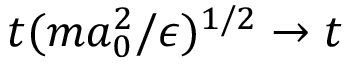<formula> <loc_0><loc_0><loc_500><loc_500>t ( m a _ { 0 } ^ { 2 } / \epsilon ) ^ { 1 / 2 } \rightarrow t</formula> 